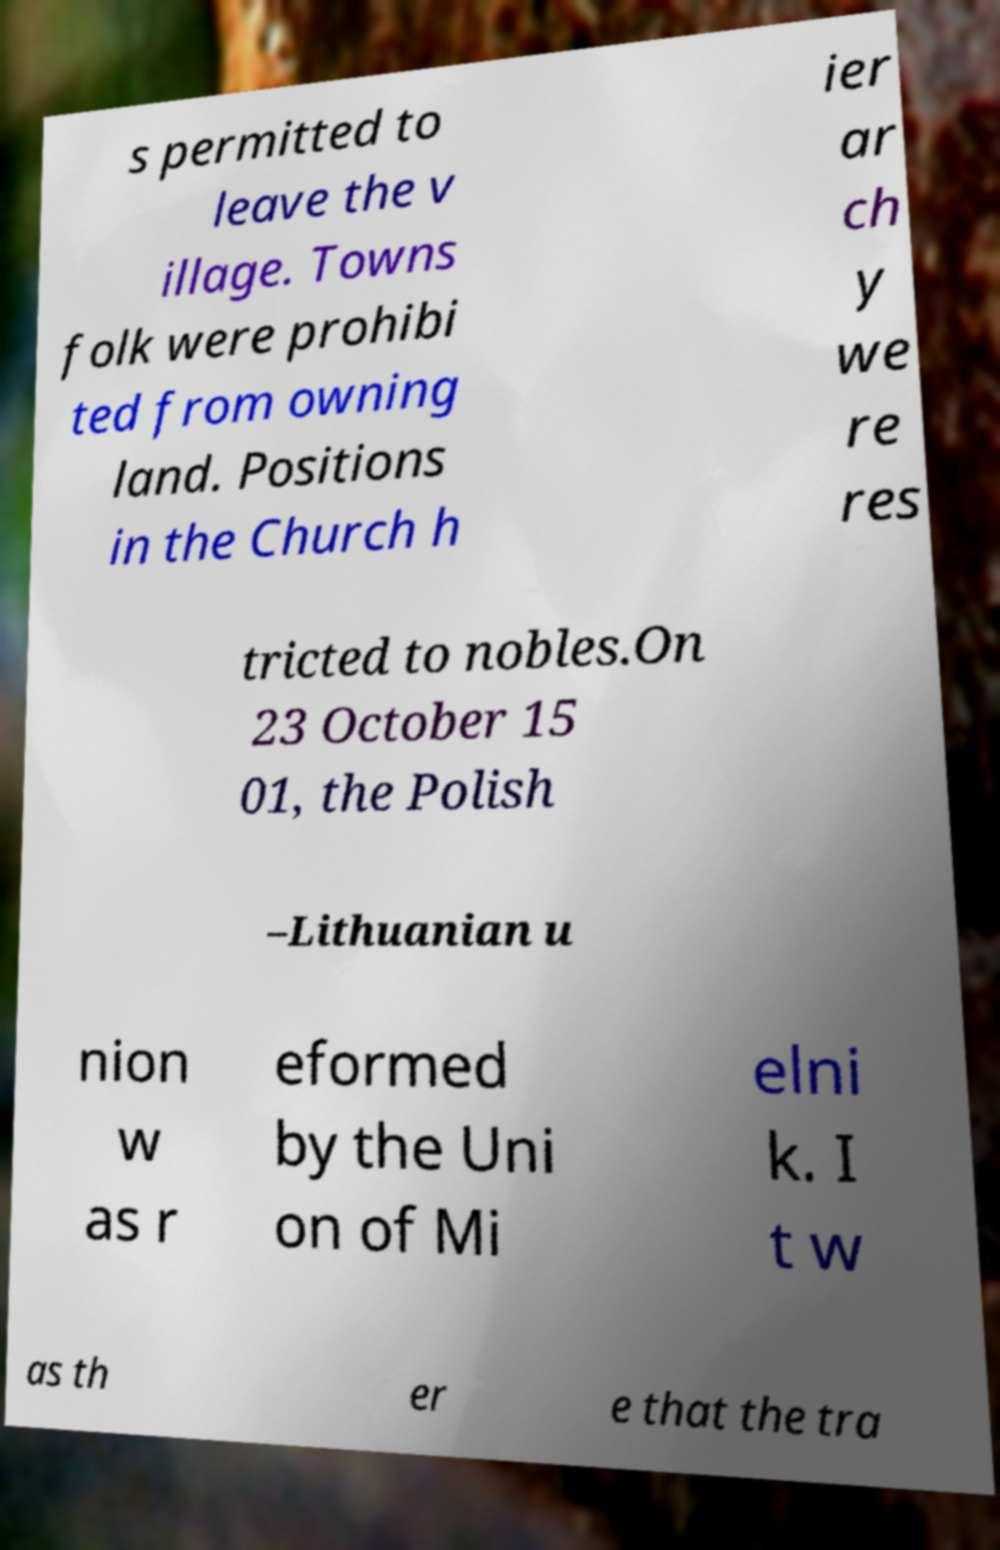Please identify and transcribe the text found in this image. s permitted to leave the v illage. Towns folk were prohibi ted from owning land. Positions in the Church h ier ar ch y we re res tricted to nobles.On 23 October 15 01, the Polish –Lithuanian u nion w as r eformed by the Uni on of Mi elni k. I t w as th er e that the tra 